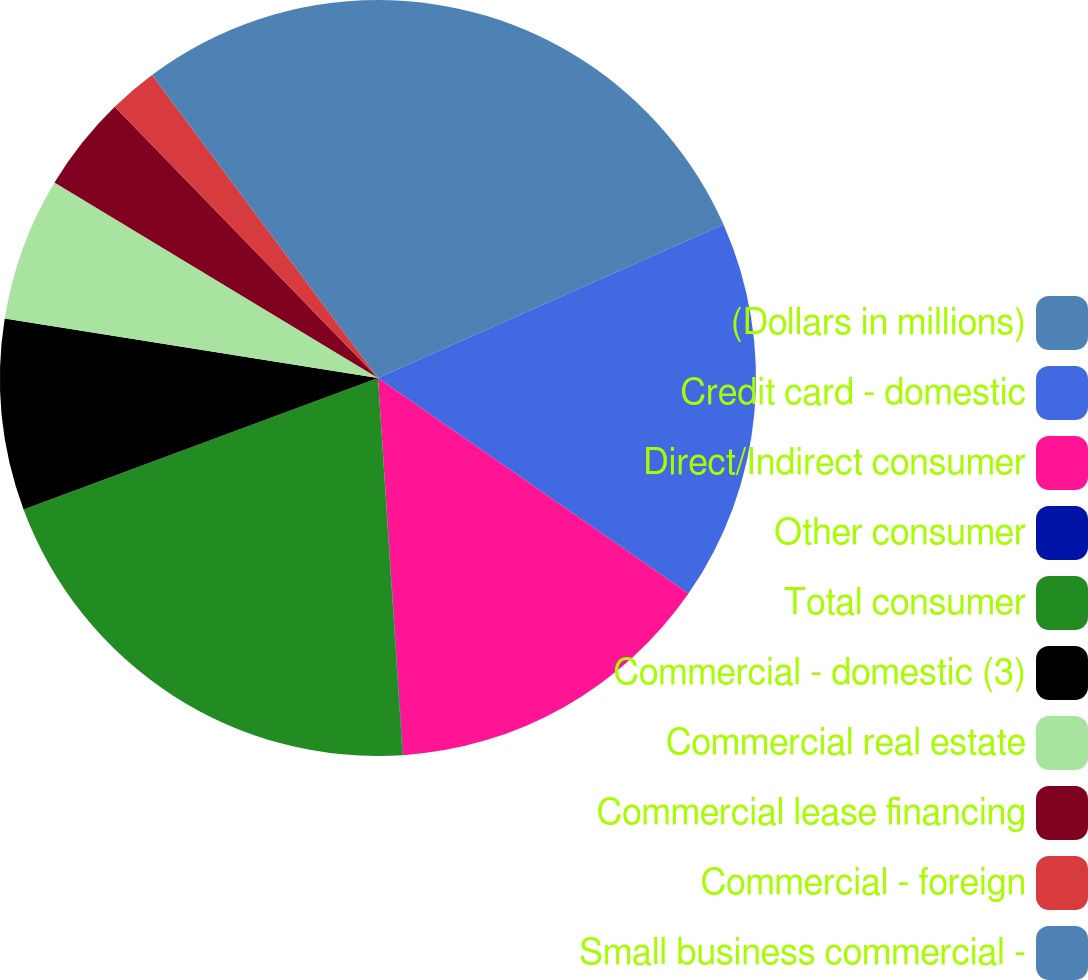Convert chart. <chart><loc_0><loc_0><loc_500><loc_500><pie_chart><fcel>(Dollars in millions)<fcel>Credit card - domestic<fcel>Direct/Indirect consumer<fcel>Other consumer<fcel>Total consumer<fcel>Commercial - domestic (3)<fcel>Commercial real estate<fcel>Commercial lease financing<fcel>Commercial - foreign<fcel>Small business commercial -<nl><fcel>18.35%<fcel>16.31%<fcel>14.28%<fcel>0.02%<fcel>20.39%<fcel>8.17%<fcel>6.13%<fcel>4.09%<fcel>2.06%<fcel>10.2%<nl></chart> 